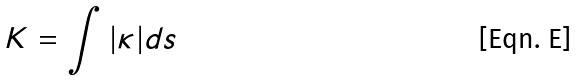Convert formula to latex. <formula><loc_0><loc_0><loc_500><loc_500>K = \int | \kappa | d s</formula> 